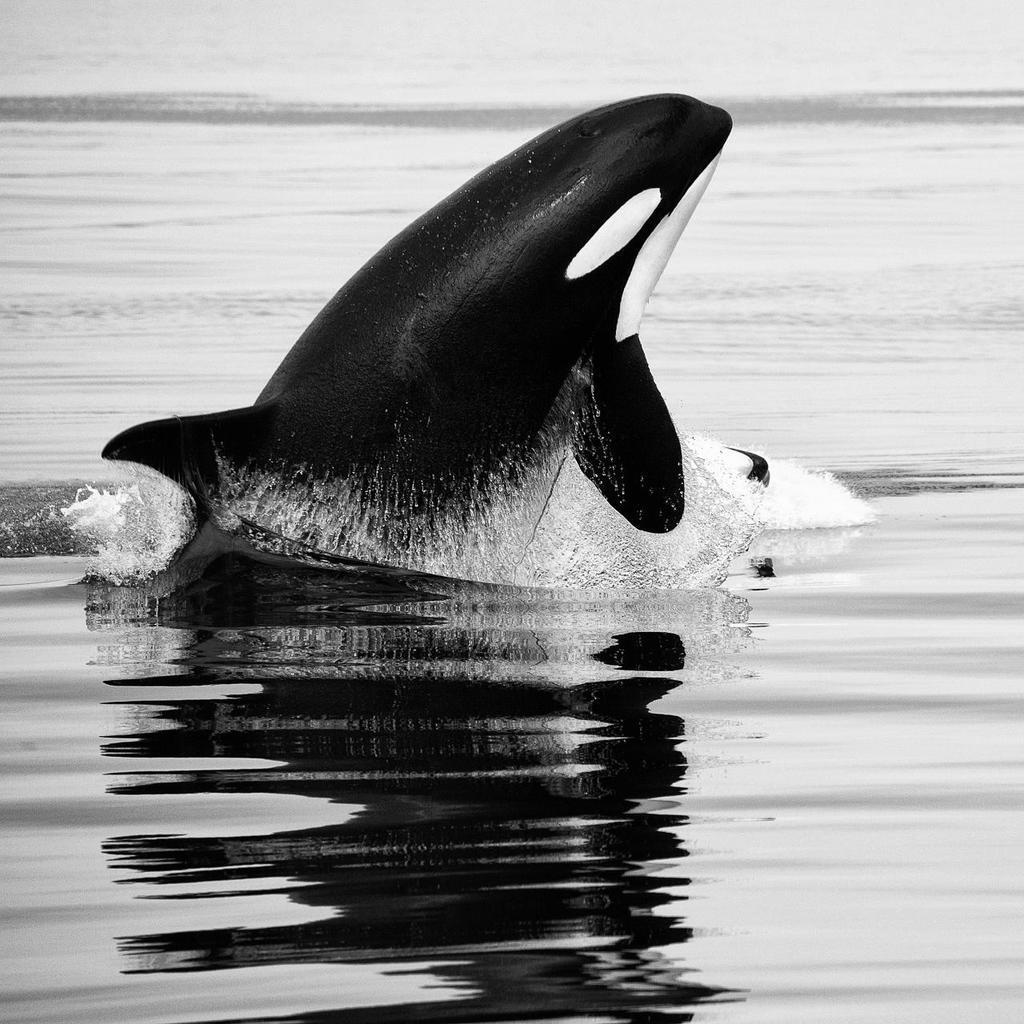How would you summarize this image in a sentence or two? In this image I can see an aquatic animal in the water. I can see this is a black and white image. 